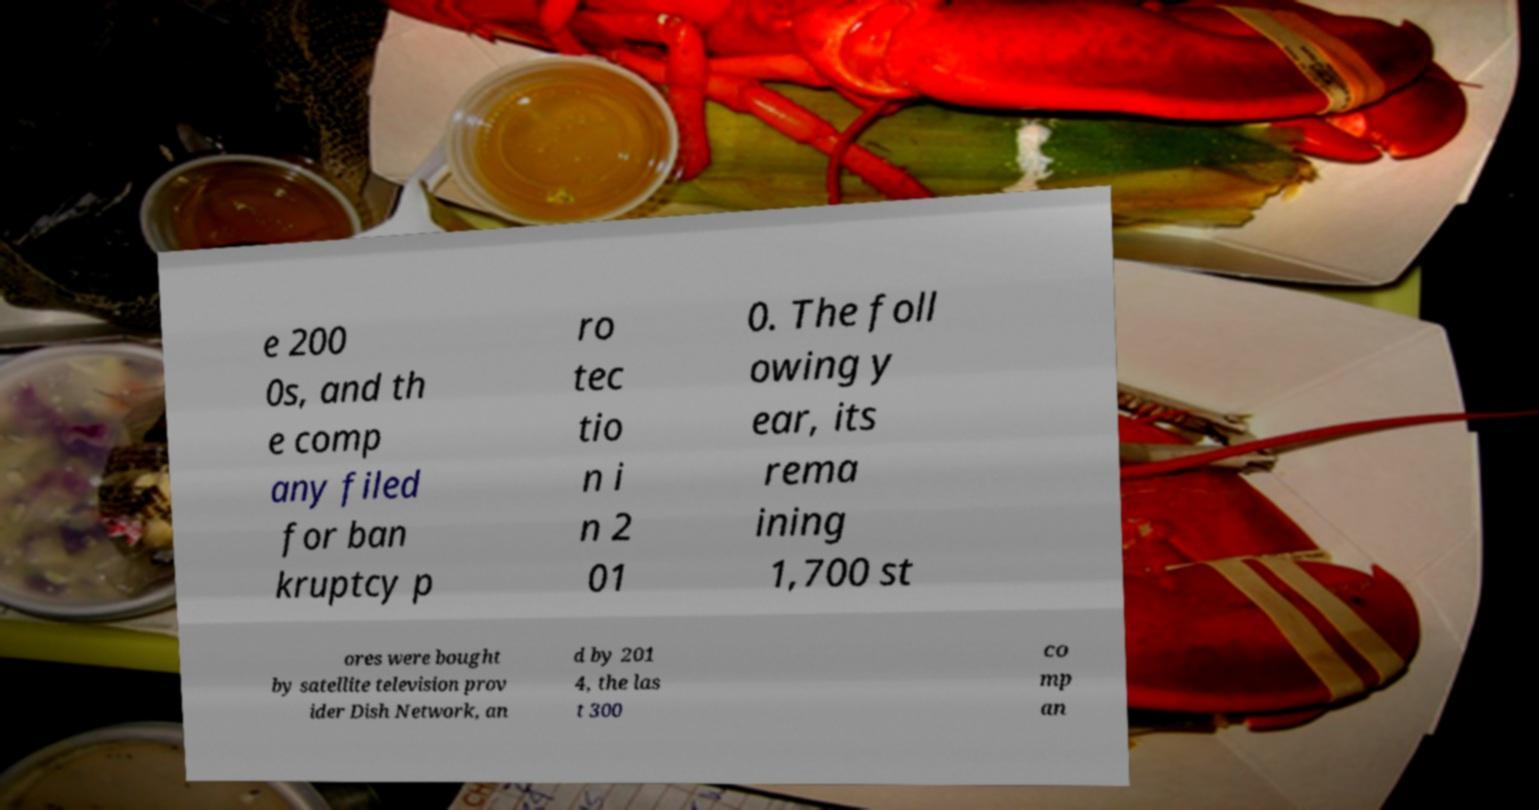Could you assist in decoding the text presented in this image and type it out clearly? e 200 0s, and th e comp any filed for ban kruptcy p ro tec tio n i n 2 01 0. The foll owing y ear, its rema ining 1,700 st ores were bought by satellite television prov ider Dish Network, an d by 201 4, the las t 300 co mp an 